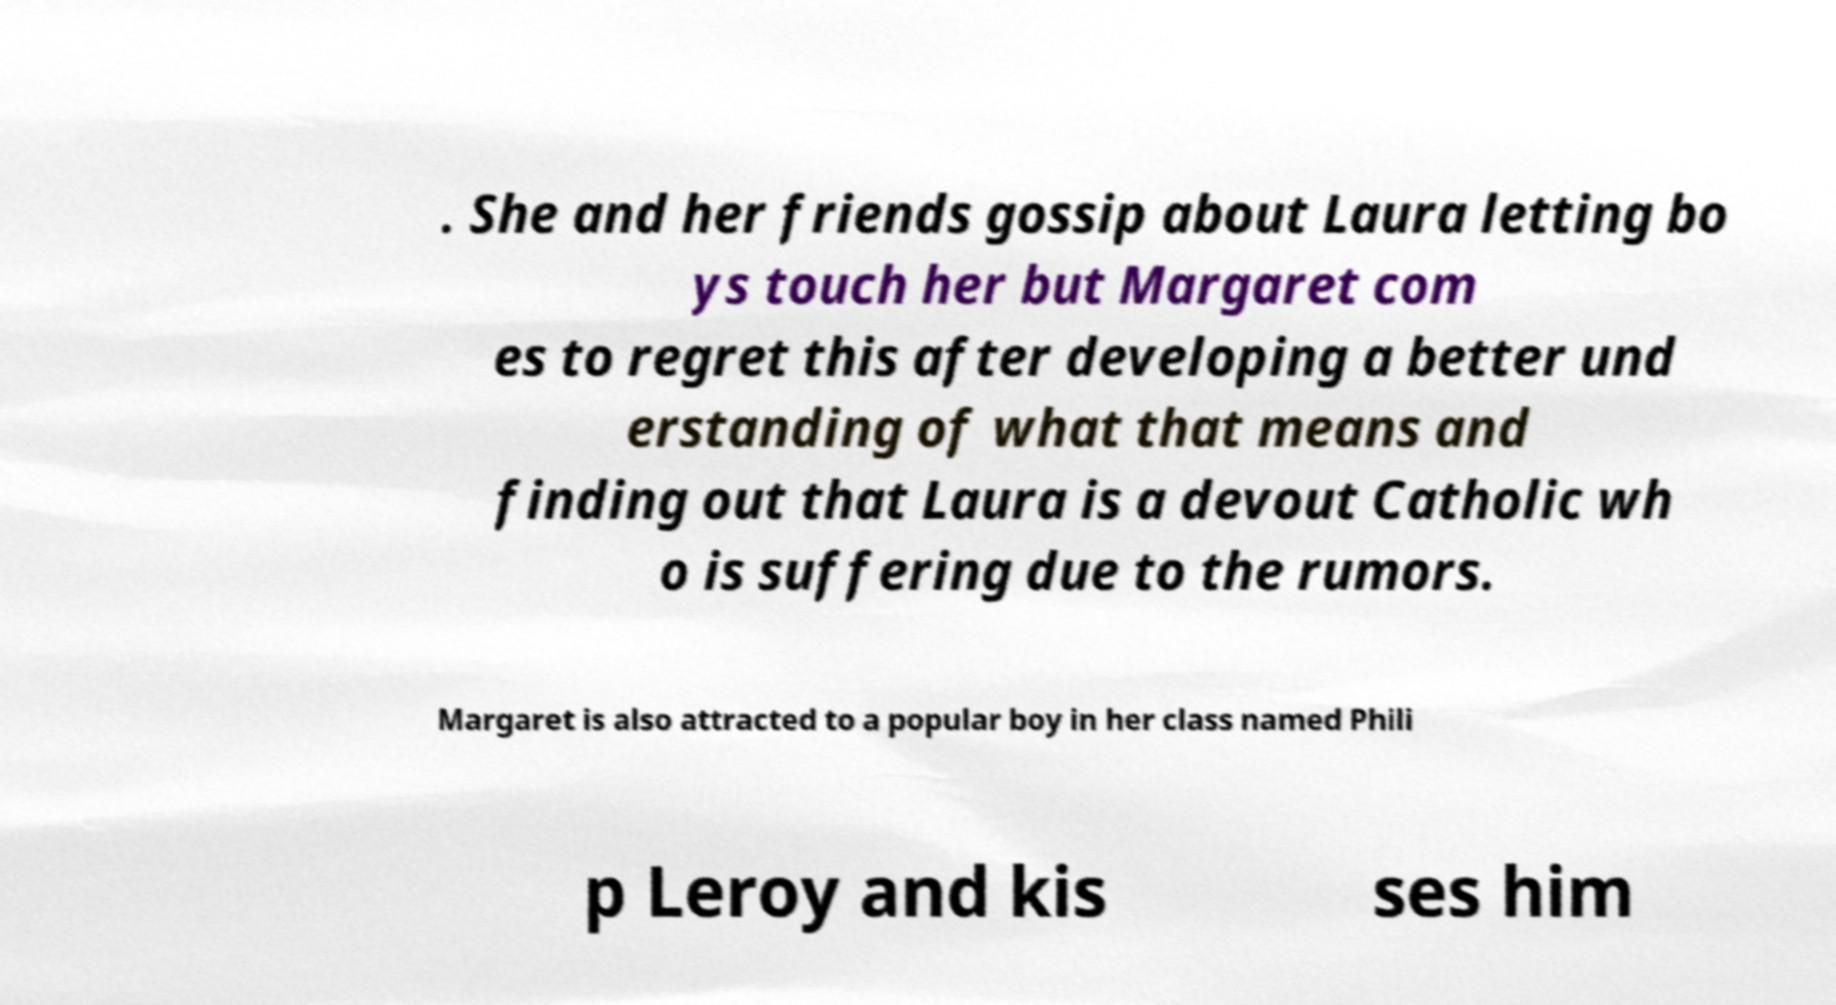Can you accurately transcribe the text from the provided image for me? . She and her friends gossip about Laura letting bo ys touch her but Margaret com es to regret this after developing a better und erstanding of what that means and finding out that Laura is a devout Catholic wh o is suffering due to the rumors. Margaret is also attracted to a popular boy in her class named Phili p Leroy and kis ses him 